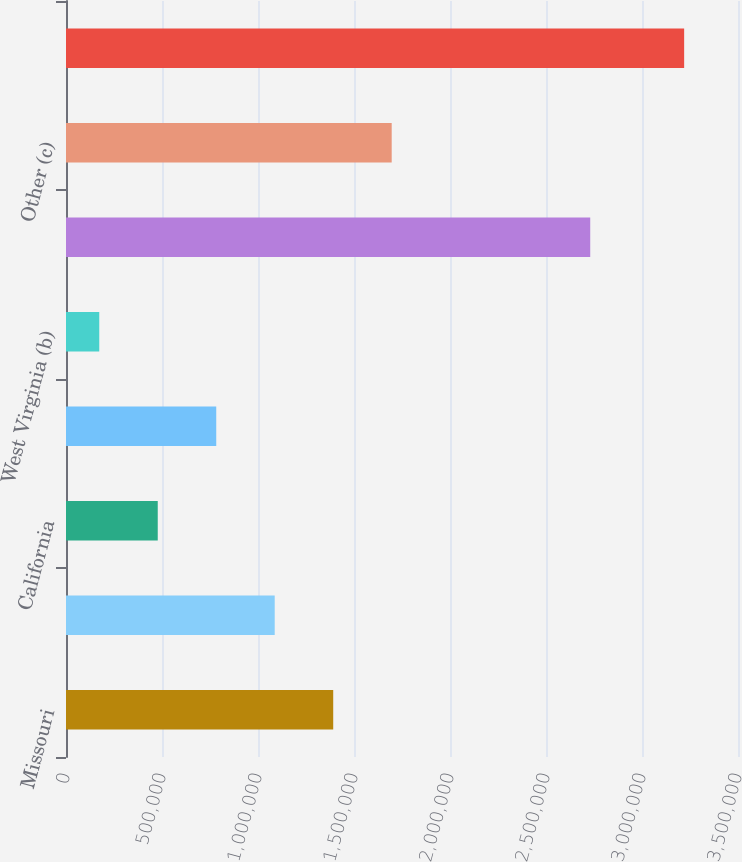Convert chart to OTSL. <chart><loc_0><loc_0><loc_500><loc_500><bar_chart><fcel>Missouri<fcel>Illinois (a)<fcel>California<fcel>Indiana<fcel>West Virginia (b)<fcel>Subtotal (Top Seven States)<fcel>Other (c)<fcel>Total Regulated Businesses<nl><fcel>1.39172e+06<fcel>1.0871e+06<fcel>477837<fcel>782466<fcel>173208<fcel>2.73035e+06<fcel>1.69635e+06<fcel>3.2195e+06<nl></chart> 